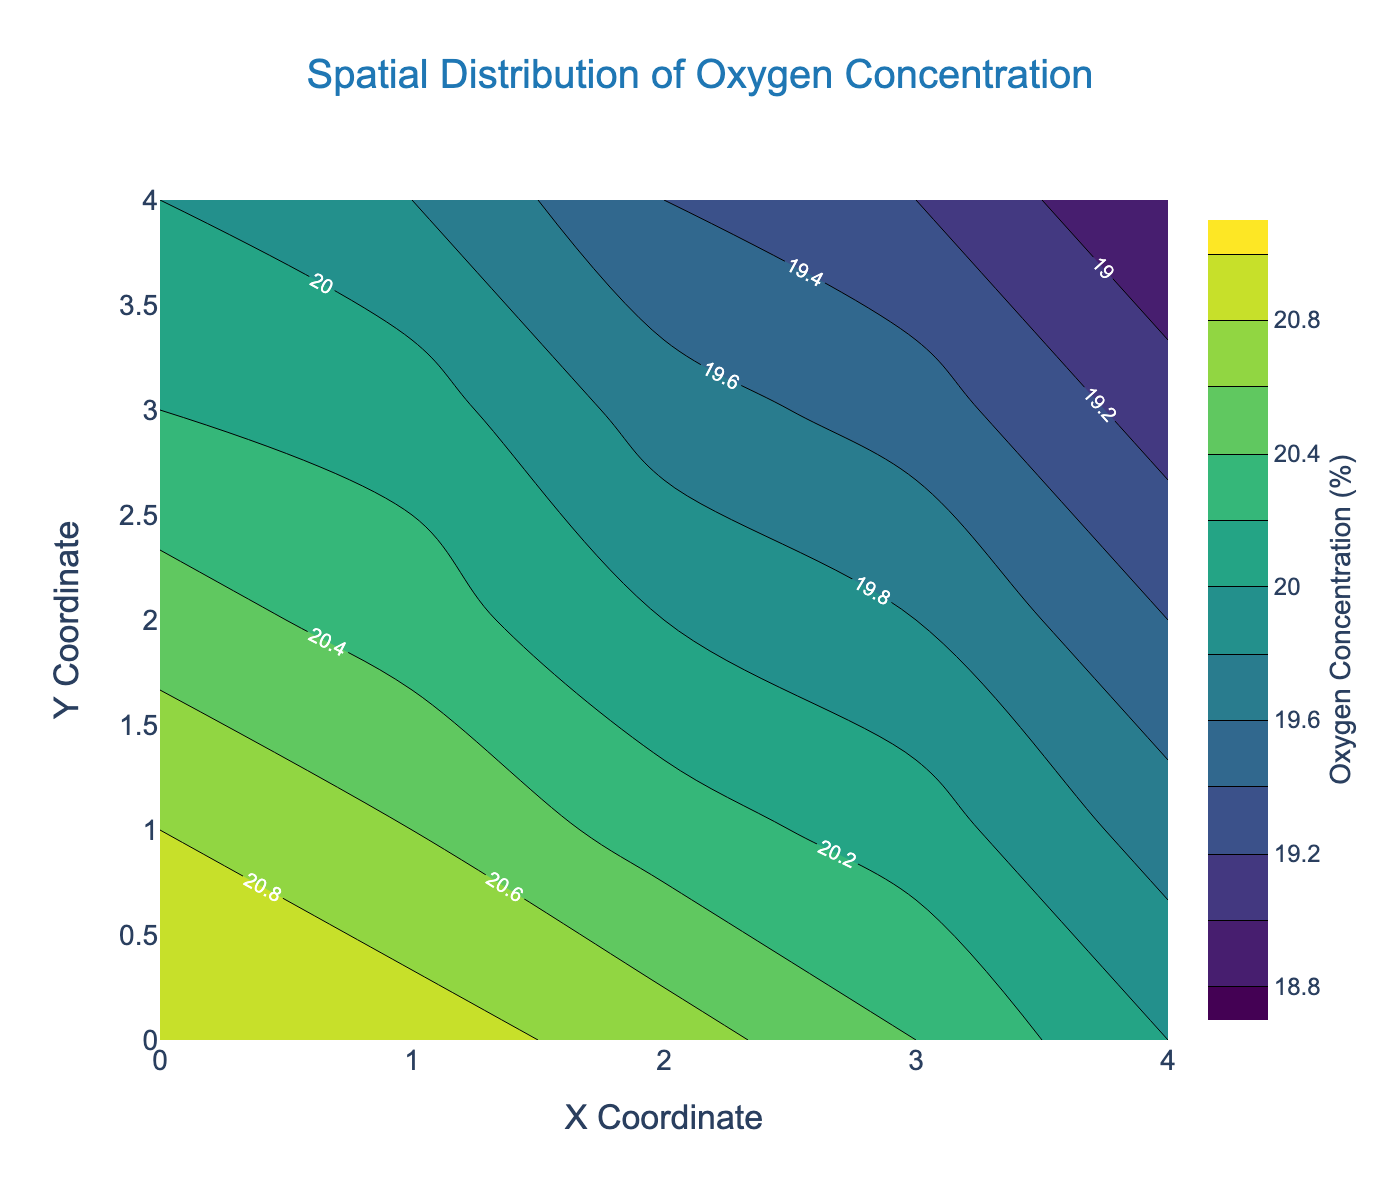What's the title of the plot? The title of the plot is usually found at the top, typically centered. In this figure, it's clearly labeled at the top.
Answer: Spatial Distribution of Oxygen Concentration What are the range values of the Oxygen Concentration as shown on the color bar? The color bar’s title is "Oxygen Concentration (%)" and it displays the range values from the start to the end limits on both sides of the gradient. By examining the color bar, we can see the limits.
Answer: 18.8 to 21 Which axis represents the Y Coordinate? Axes are typically labeled on the plot with titles at their ends. In this figure, you can find "Y Coordinate" on the left side of the vertical axis.
Answer: The vertical axis Where is the lowest oxygen concentration located in the culture environment? To find the lowest oxygen concentration, look at the contour labels and the color gradient. The darkest color usually corresponds to the lowest value. The labels indicate this occurs at (4,4).
Answer: (4,4) Does the oxygen concentration generally increase or decrease from left to right along the X Coordinate? To determine this, examine the contour levels and color changes from left (X=0) to right (X=4). The lighter colors, indicating higher concentrations, primarily reside on the left.
Answer: Decrease What is the value of oxygen concentration at (0,0) and (4,4)? The specific values can be read directly from the contour labels at the given coordinates. At (0,0), it's labeled as 21.0 and at (4,4) it's 18.8.
Answer: 21.0 and 18.8 Compare the oxygen concentration at (2,2) and (3,3). Which one is higher? Locate the contour labels at (2,2) and (3,3). According to the figure, the oxygen concentration at (2,2) is 20 and at (3,3) is 19.5.
Answer: (2,2) is higher Identify areas with oxygen concentration between 19 and 20. Look at the contour lines and labels. The regions with labels between 19 and 20 appear in the middle and lower parts of the plot. These areas are roughly centered around (2,2) and downward.
Answer: Middle and lower parts What is the trend of oxygen concentration along the Y Coordinate at X = 2? Trace the vertical line at X = 2 and note the changes in contour labels. They indicate a decreasing trend from top (20.7) to bottom (19.4).
Answer: Decrease from top to bottom At which coordinates is the oxygen concentration exactly 20.0? Scan the plot for contour labels that show the value 20.0. It appears at two points: (0,4) and (2,2).
Answer: (0,4) and (2,2) 